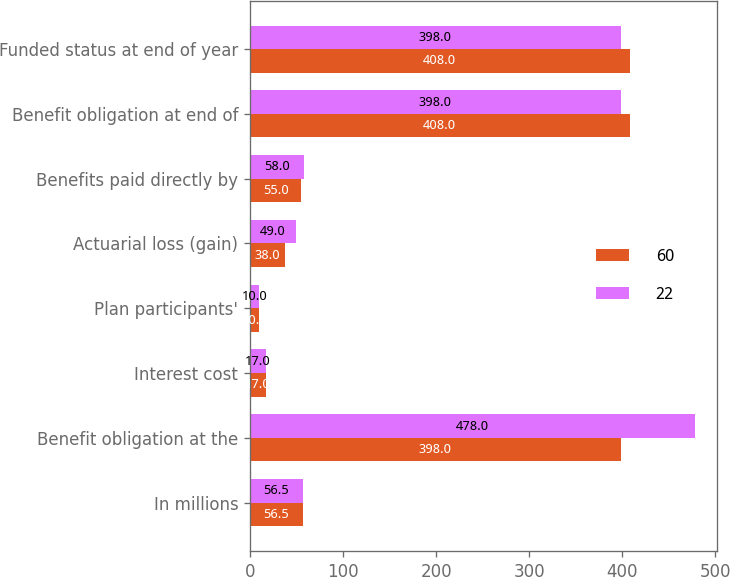<chart> <loc_0><loc_0><loc_500><loc_500><stacked_bar_chart><ecel><fcel>In millions<fcel>Benefit obligation at the<fcel>Interest cost<fcel>Plan participants'<fcel>Actuarial loss (gain)<fcel>Benefits paid directly by<fcel>Benefit obligation at end of<fcel>Funded status at end of year<nl><fcel>60<fcel>56.5<fcel>398<fcel>17<fcel>10<fcel>38<fcel>55<fcel>408<fcel>408<nl><fcel>22<fcel>56.5<fcel>478<fcel>17<fcel>10<fcel>49<fcel>58<fcel>398<fcel>398<nl></chart> 